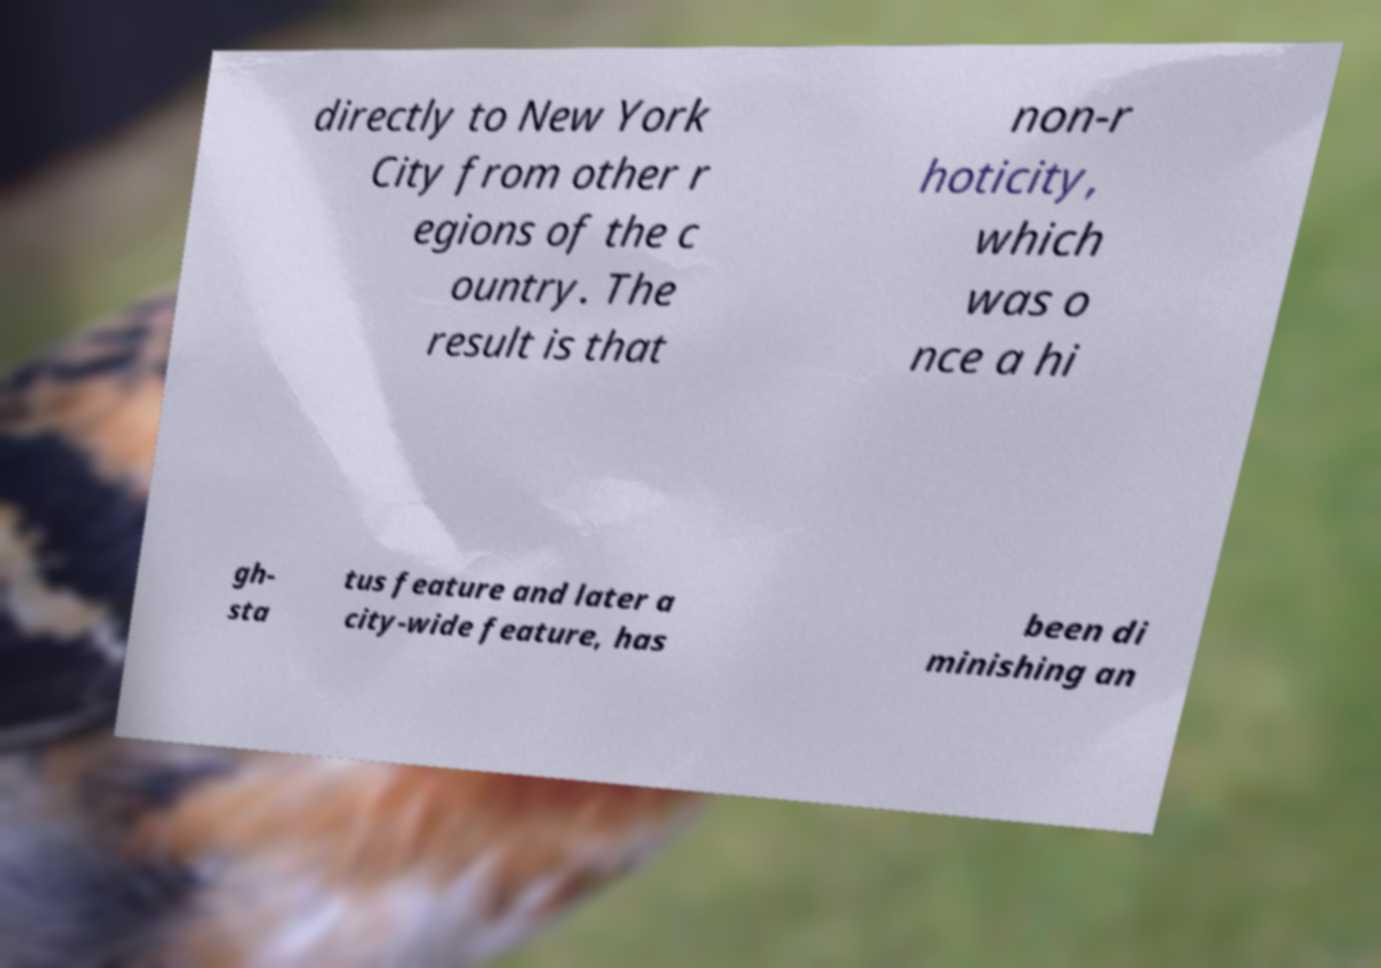Could you extract and type out the text from this image? directly to New York City from other r egions of the c ountry. The result is that non-r hoticity, which was o nce a hi gh- sta tus feature and later a city-wide feature, has been di minishing an 